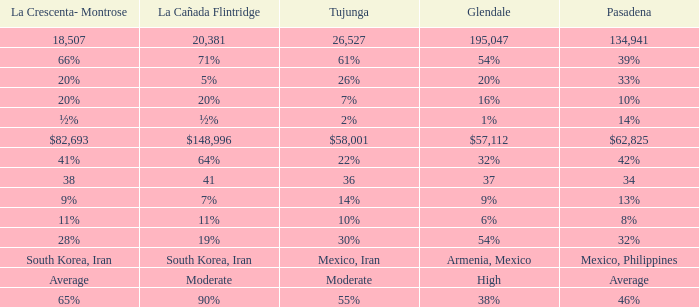What is the figure for La Canada Flintridge when Pasadena is 34? 41.0. 